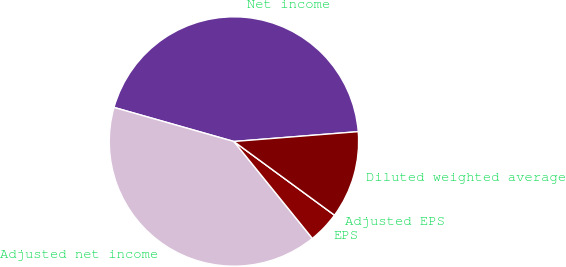Convert chart to OTSL. <chart><loc_0><loc_0><loc_500><loc_500><pie_chart><fcel>Net income<fcel>Adjusted net income<fcel>EPS<fcel>Adjusted EPS<fcel>Diluted weighted average<nl><fcel>44.34%<fcel>40.24%<fcel>4.11%<fcel>0.0%<fcel>11.32%<nl></chart> 